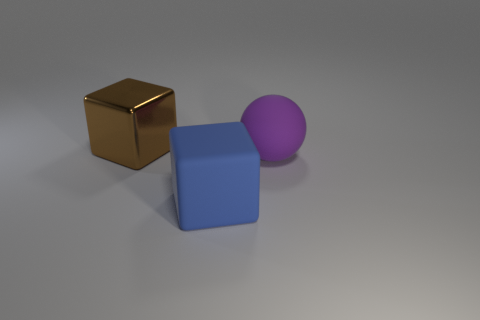Add 1 large spheres. How many objects exist? 4 Subtract all balls. How many objects are left? 2 Add 1 rubber balls. How many rubber balls are left? 2 Add 1 purple matte spheres. How many purple matte spheres exist? 2 Subtract 0 gray cylinders. How many objects are left? 3 Subtract all purple rubber things. Subtract all tiny blue metallic balls. How many objects are left? 2 